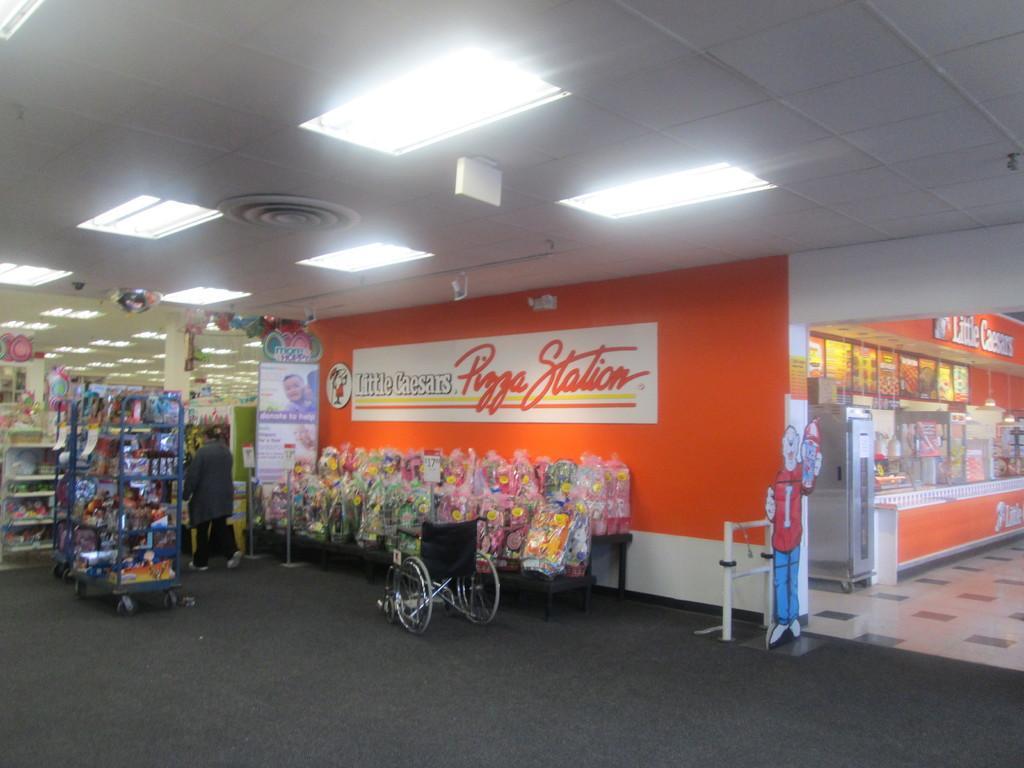Can you describe this image briefly? In this picture I can see woman walking and a wheelchair and I can see few items in the shelves and the picture looks like a inner view of a store and I can see text on the walls and I can see a board with some text and few lights on the ceiling. 